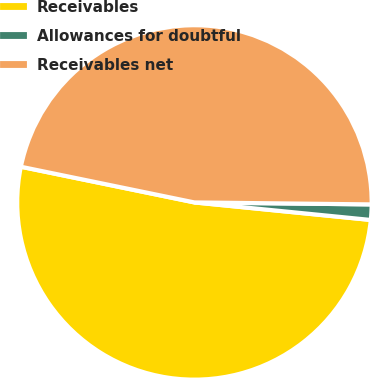<chart> <loc_0><loc_0><loc_500><loc_500><pie_chart><fcel>Receivables<fcel>Allowances for doubtful<fcel>Receivables net<nl><fcel>51.65%<fcel>1.4%<fcel>46.95%<nl></chart> 